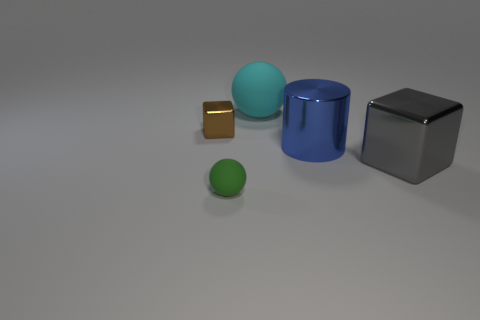Are there any other things that have the same shape as the blue object?
Offer a terse response. No. How many red things are balls or tiny metal things?
Your answer should be very brief. 0. There is a brown thing; are there any spheres in front of it?
Provide a short and direct response. Yes. What is the size of the gray block?
Keep it short and to the point. Large. What size is the other object that is the same shape as the cyan rubber object?
Make the answer very short. Small. There is a large ball to the left of the gray cube; what number of matte spheres are left of it?
Offer a terse response. 1. Are the cube that is on the right side of the tiny rubber thing and the small thing that is behind the big gray block made of the same material?
Provide a succinct answer. Yes. How many other small things have the same shape as the cyan object?
Give a very brief answer. 1. What number of tiny rubber objects have the same color as the large shiny cube?
Your answer should be very brief. 0. Does the large metallic thing left of the big gray shiny thing have the same shape as the rubber object that is behind the tiny green thing?
Your response must be concise. No. 